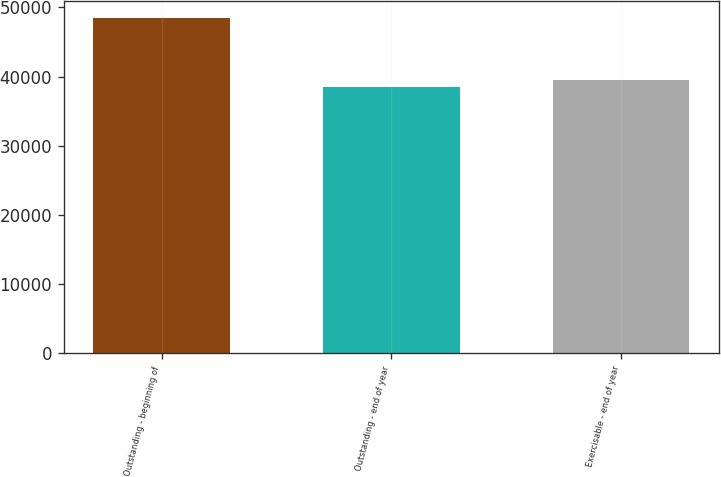Convert chart. <chart><loc_0><loc_0><loc_500><loc_500><bar_chart><fcel>Outstanding - beginning of<fcel>Outstanding - end of year<fcel>Exercisable - end of year<nl><fcel>48446<fcel>38454<fcel>39453.2<nl></chart> 